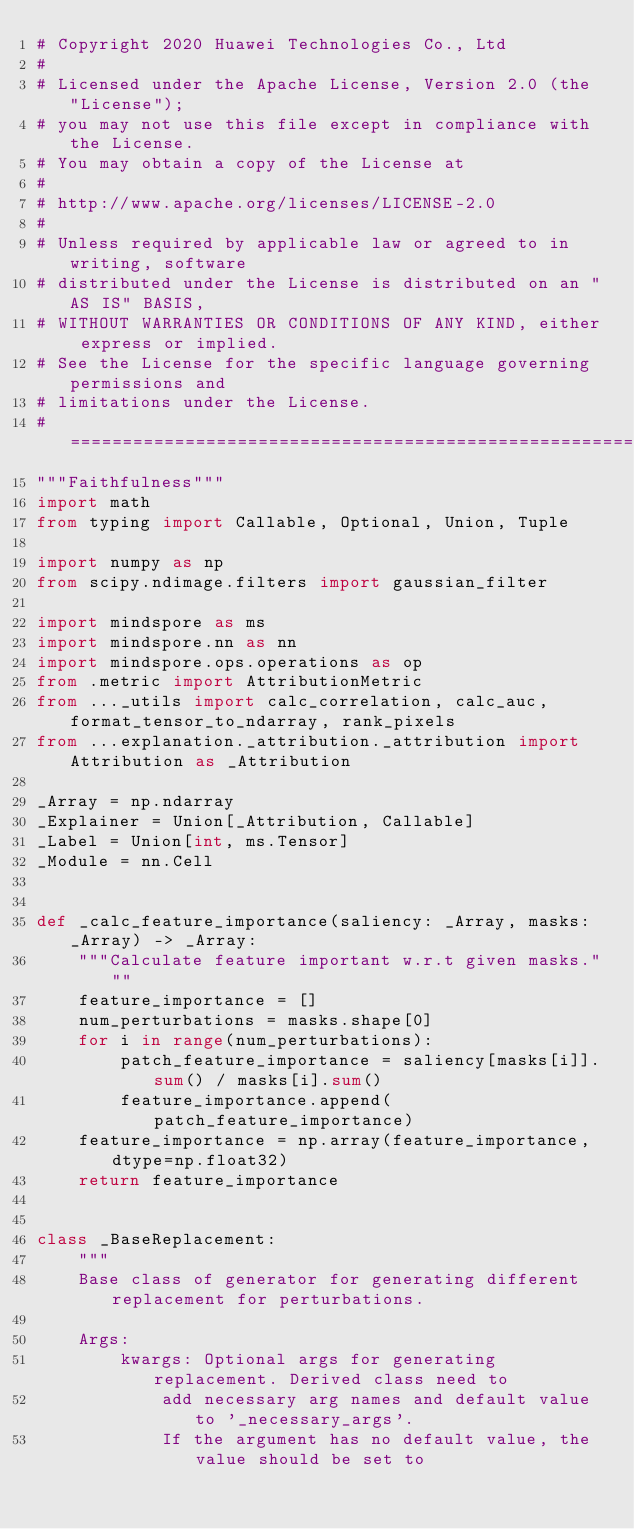Convert code to text. <code><loc_0><loc_0><loc_500><loc_500><_Python_># Copyright 2020 Huawei Technologies Co., Ltd
#
# Licensed under the Apache License, Version 2.0 (the "License");
# you may not use this file except in compliance with the License.
# You may obtain a copy of the License at
#
# http://www.apache.org/licenses/LICENSE-2.0
#
# Unless required by applicable law or agreed to in writing, software
# distributed under the License is distributed on an "AS IS" BASIS,
# WITHOUT WARRANTIES OR CONDITIONS OF ANY KIND, either express or implied.
# See the License for the specific language governing permissions and
# limitations under the License.
# ============================================================================
"""Faithfulness"""
import math
from typing import Callable, Optional, Union, Tuple

import numpy as np
from scipy.ndimage.filters import gaussian_filter

import mindspore as ms
import mindspore.nn as nn
import mindspore.ops.operations as op
from .metric import AttributionMetric
from ..._utils import calc_correlation, calc_auc, format_tensor_to_ndarray, rank_pixels
from ...explanation._attribution._attribution import Attribution as _Attribution

_Array = np.ndarray
_Explainer = Union[_Attribution, Callable]
_Label = Union[int, ms.Tensor]
_Module = nn.Cell


def _calc_feature_importance(saliency: _Array, masks: _Array) -> _Array:
    """Calculate feature important w.r.t given masks."""
    feature_importance = []
    num_perturbations = masks.shape[0]
    for i in range(num_perturbations):
        patch_feature_importance = saliency[masks[i]].sum() / masks[i].sum()
        feature_importance.append(patch_feature_importance)
    feature_importance = np.array(feature_importance, dtype=np.float32)
    return feature_importance


class _BaseReplacement:
    """
    Base class of generator for generating different replacement for perturbations.

    Args:
        kwargs: Optional args for generating replacement. Derived class need to
            add necessary arg names and default value to '_necessary_args'.
            If the argument has no default value, the value should be set to</code> 